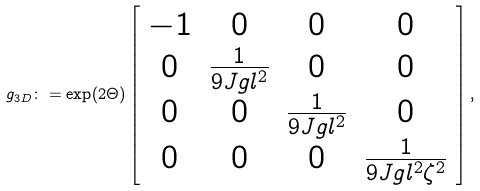<formula> <loc_0><loc_0><loc_500><loc_500>g _ { 3 D } \colon = \exp ( 2 \Theta ) \left [ \begin{array} { c c c c } - 1 & 0 & 0 & 0 \\ 0 & \frac { 1 } { 9 J g l ^ { 2 } } & 0 & 0 \\ 0 & 0 & \frac { 1 } { 9 J g l ^ { 2 } } & 0 \\ 0 & 0 & 0 & \frac { 1 } { 9 J g l ^ { 2 } \zeta ^ { 2 } } \end{array} \right ] ,</formula> 